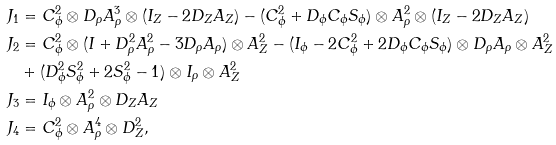<formula> <loc_0><loc_0><loc_500><loc_500>J _ { 1 } & = C ^ { 2 } _ { \phi } \otimes D _ { \rho } A _ { \rho } ^ { 3 } \otimes ( I _ { Z } - 2 D _ { Z } A _ { Z } ) - ( C ^ { 2 } _ { \phi } + D _ { \phi } C _ { \phi } S _ { \phi } ) \otimes A _ { \rho } ^ { 2 } \otimes ( I _ { Z } - 2 D _ { Z } A _ { Z } ) \\ J _ { 2 } & = C ^ { 2 } _ { \phi } \otimes ( I + D _ { \rho } ^ { 2 } A _ { \rho } ^ { 2 } - 3 D _ { \rho } A _ { \rho } ) \otimes A _ { Z } ^ { 2 } - ( I _ { \phi } - 2 C ^ { 2 } _ { \phi } + 2 D _ { \phi } C _ { \phi } S _ { \phi } ) \otimes D _ { \rho } A _ { \rho } \otimes A _ { Z } ^ { 2 } \\ & + ( D _ { \phi } ^ { 2 } S ^ { 2 } _ { \phi } + 2 S ^ { 2 } _ { \phi } - 1 ) \otimes I _ { \rho } \otimes A _ { Z } ^ { 2 } \\ J _ { 3 } & = I _ { \phi } \otimes A _ { \rho } ^ { 2 } \otimes D _ { Z } A _ { Z } \\ J _ { 4 } & = C ^ { 2 } _ { \phi } \otimes A _ { \rho } ^ { 4 } \otimes D ^ { 2 } _ { Z } ,</formula> 